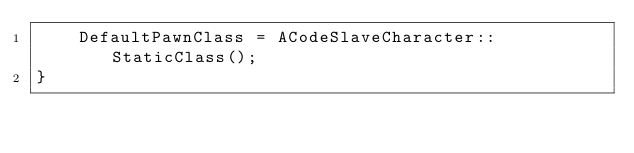Convert code to text. <code><loc_0><loc_0><loc_500><loc_500><_C++_>	DefaultPawnClass = ACodeSlaveCharacter::StaticClass();	
}
</code> 